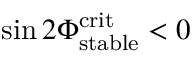<formula> <loc_0><loc_0><loc_500><loc_500>\sin 2 \Phi _ { s t a b l e } ^ { c r i t } < 0</formula> 